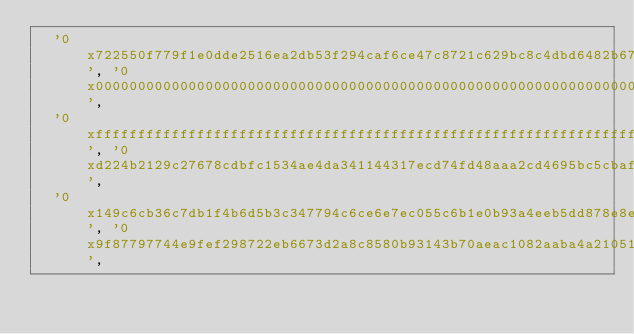<code> <loc_0><loc_0><loc_500><loc_500><_YAML_>  '0x722550f779f1e0dde2516ea2db53f294caf6ce47c8721c629bc8c4dbd6482b67', '0x0000000000000000000000000000000000000000000000000000000000000000',
  '0xffffffffffffffffffffffffffffffffffffffffffffffffffffffffffffffff', '0xd224b2129c27678cdbfc1534ae4da341144317ecd74fd48aaa2cd4695bc5cbaf',
  '0x149c6cb36c7db1f4b6d5b3c347794c6ce6e7ec055c6b1e0b93a4eeb5dd878e8e', '0x9f87797744e9fef298722eb6673d2a8c8580b93143b70aeac1082aaba4a21051',</code> 